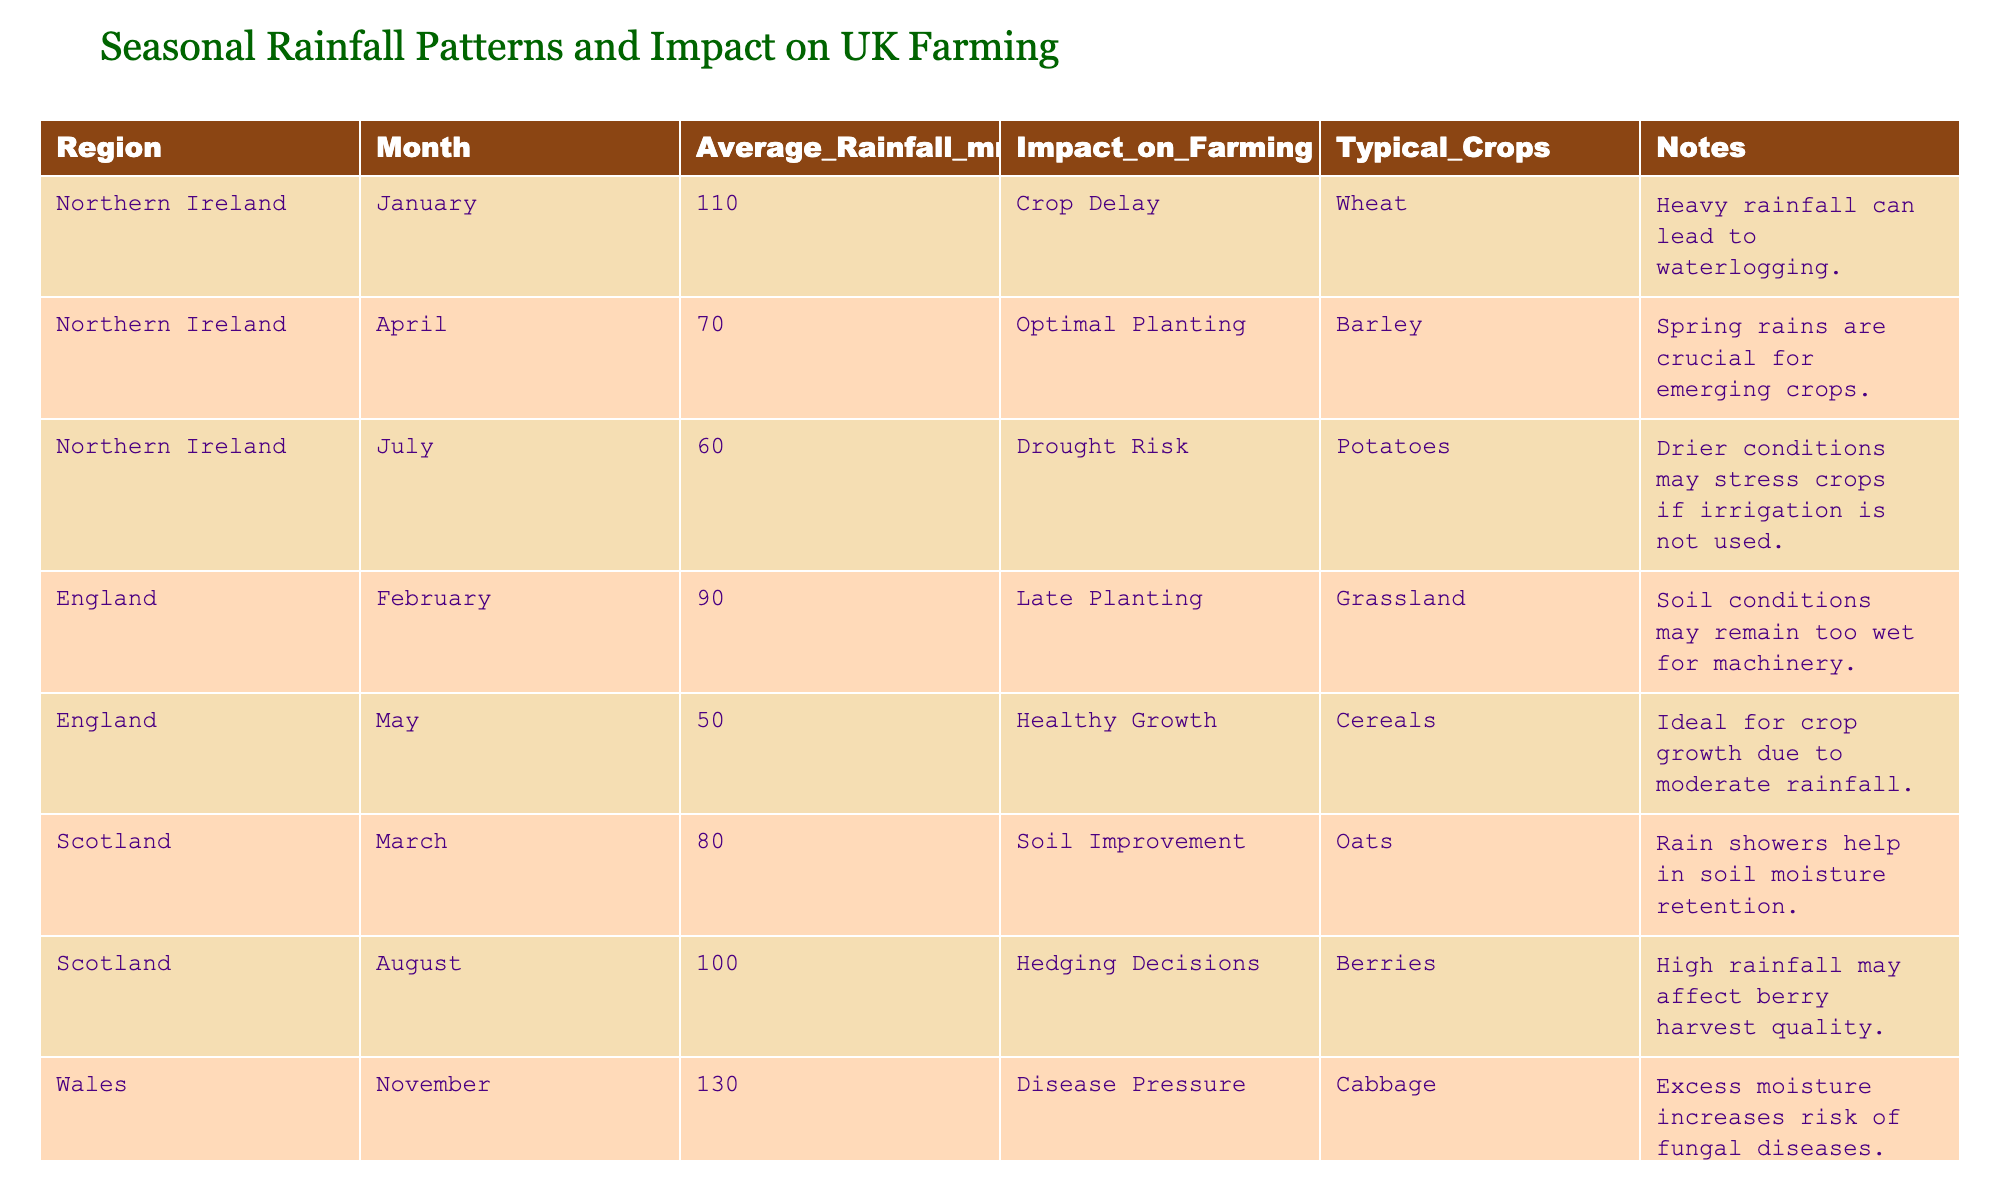What is the average rainfall in Northern Ireland during July? The average rainfall for Northern Ireland in July is given directly in the table as 60 mm.
Answer: 60 mm Which region has the highest average rainfall in November? The table indicates that Wales has the highest average rainfall in November at 130 mm.
Answer: Wales Is the impact of rainfall in April in Northern Ireland categorized as optimal planting? According to the table, the impact of rainfall in April for Northern Ireland is indeed categorized as optimal planting.
Answer: Yes How does the average rainfall in England in May compare to that in February? The average rainfall in May is 50 mm, while in February, it is 90 mm. The difference is 90 mm - 50 mm = 40 mm, indicating that May has less rainfall than February.
Answer: 40 mm less Which typical crop is impacted by heavy rainfall in January in Northern Ireland? The table specifies that heavy rainfall in January leads to crop delay, and the typical crop affected is wheat.
Answer: Wheat How many regions report a healthy growth impact during the growing season? The table shows that only England reports a healthy growth impact in May. Therefore, the count is one.
Answer: 1 In which month does Scotland experience the highest reported average rainfall? Analyzing the table, the highest average rainfall in Scotland is in August, with 100 mm.
Answer: August Are drier conditions in July a risk for potatoes in Northern Ireland? Yes, the table states that drier conditions may stress crops like potatoes in July, indicating a risk.
Answer: Yes What is the total average rainfall for Northern Ireland across January, April, and July? The average rainfall for Northern Ireland in January is 110 mm, in April is 70 mm, and in July is 60 mm. Adding these gives a total of 110 + 70 + 60 = 240 mm.
Answer: 240 mm 